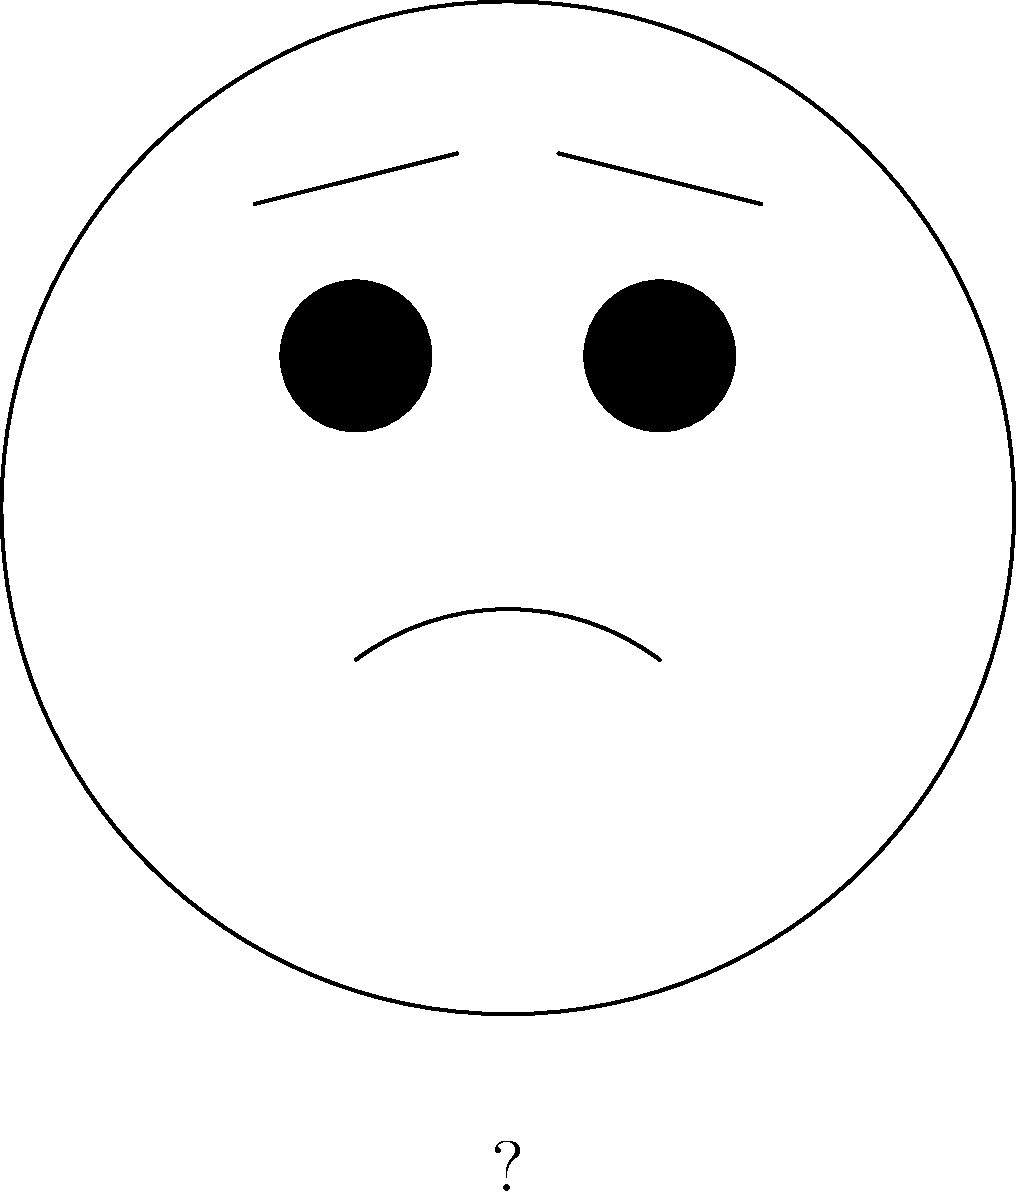In a facial recognition system for emotion detection, what emotion would likely be associated with the facial features shown in the image above? To determine the emotion associated with the facial features in the image, let's analyze the key components step-by-step:

1. Eyes: The eyes are wide open, indicated by the fully circular shape.
2. Eyebrows: The eyebrows are slightly raised, shown by their upward curve.
3. Mouth: There is a slight upward curve to the mouth, suggesting a subtle smile.

These facial features typically correspond to the emotion of surprise, often mixed with a hint of pleasure or happiness. The raised eyebrows and wide eyes are classic indicators of surprise, while the slight smile suggests a positive reaction to the surprising stimulus.

In machine learning for emotion recognition, these features would be quantified and analyzed. The system would likely be trained on thousands of images with labeled emotions, learning to associate specific facial muscle movements and positions with different emotional states.

For a high school student working on independent projects due to their mother's frequent travels, understanding these nuances in facial expressions could be particularly relevant. It might help in developing better communication skills or even in creating emotion recognition algorithms for personal projects or science fairs.
Answer: Surprise (with a hint of pleasure) 